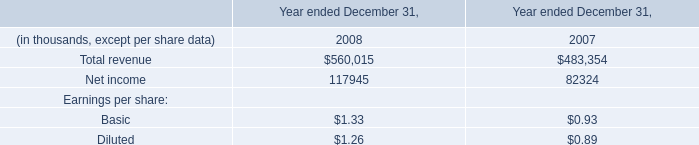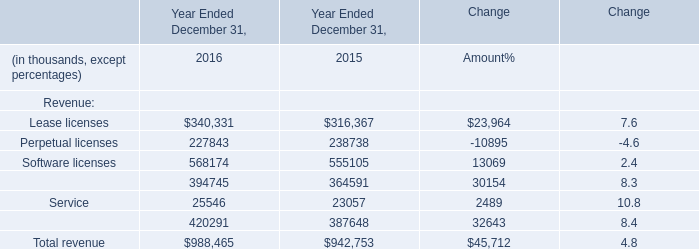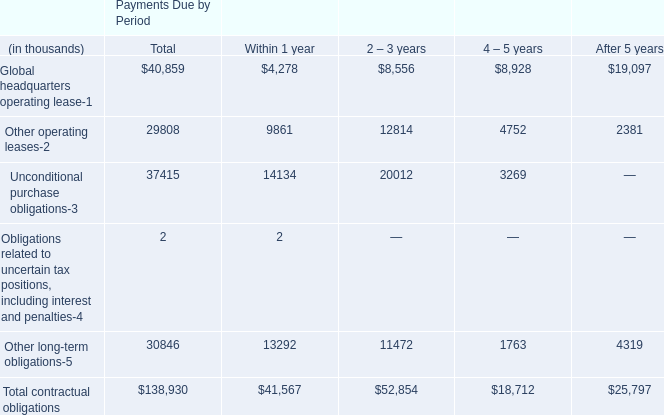If Lease licenses develops with the same increasing rate in 2016, what will it reach in 2017? (in million) 
Computations: ((1 + ((340331 - 316367) / 316367)) * 340331)
Answer: 366110.21238. 